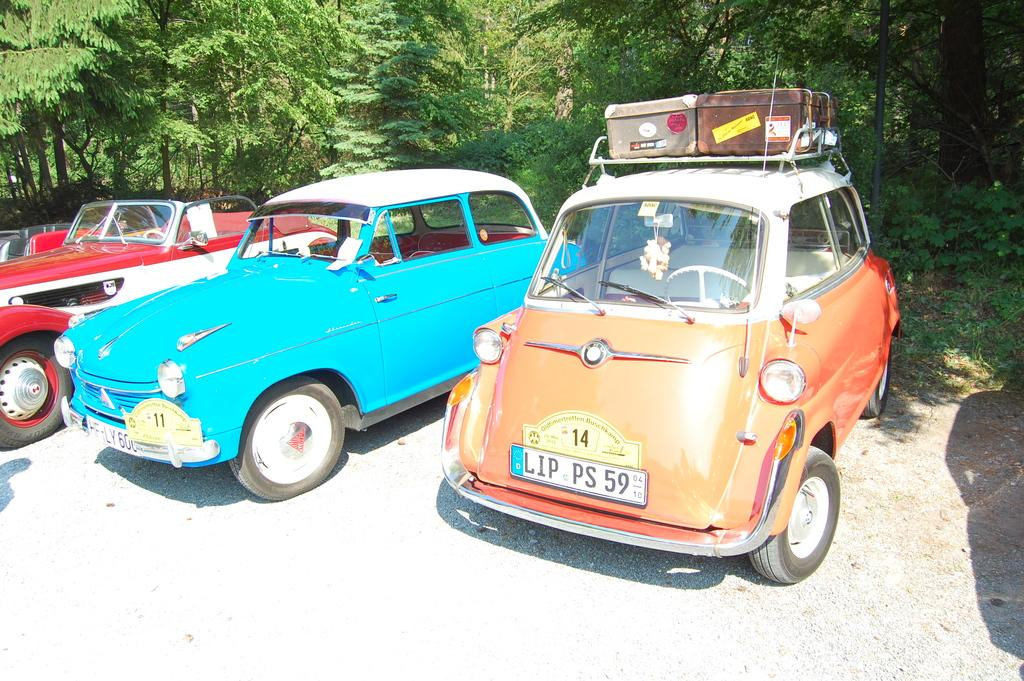What can be seen in the image in terms of transportation? There are many vehicles in the image. What distinguishing features do the vehicles have? The vehicles have numbers and number plates. Can you describe any additional items related to the vehicles? There is luggage on at least one of the vehicles. What can be seen in the background of the image? The sky is visible in the background of the image. What type of soup is being served in the alley in the image? There is no soup or alley present in the image; it features vehicles with numbers and number plates, luggage, and a visible sky in the background. 